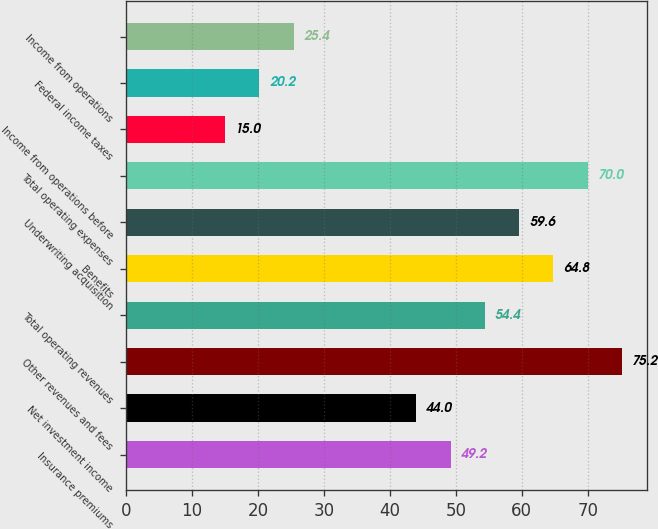Convert chart. <chart><loc_0><loc_0><loc_500><loc_500><bar_chart><fcel>Insurance premiums<fcel>Net investment income<fcel>Other revenues and fees<fcel>Total operating revenues<fcel>Benefits<fcel>Underwriting acquisition<fcel>Total operating expenses<fcel>Income from operations before<fcel>Federal income taxes<fcel>Income from operations<nl><fcel>49.2<fcel>44<fcel>75.2<fcel>54.4<fcel>64.8<fcel>59.6<fcel>70<fcel>15<fcel>20.2<fcel>25.4<nl></chart> 